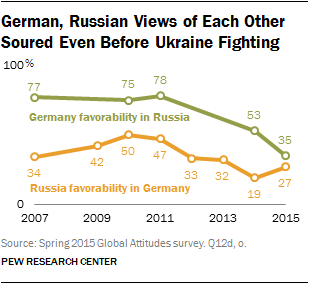Mention a couple of crucial points in this snapshot. The color of a graph whose lowest value is 35 is green. The median value of the green graph is 75. 